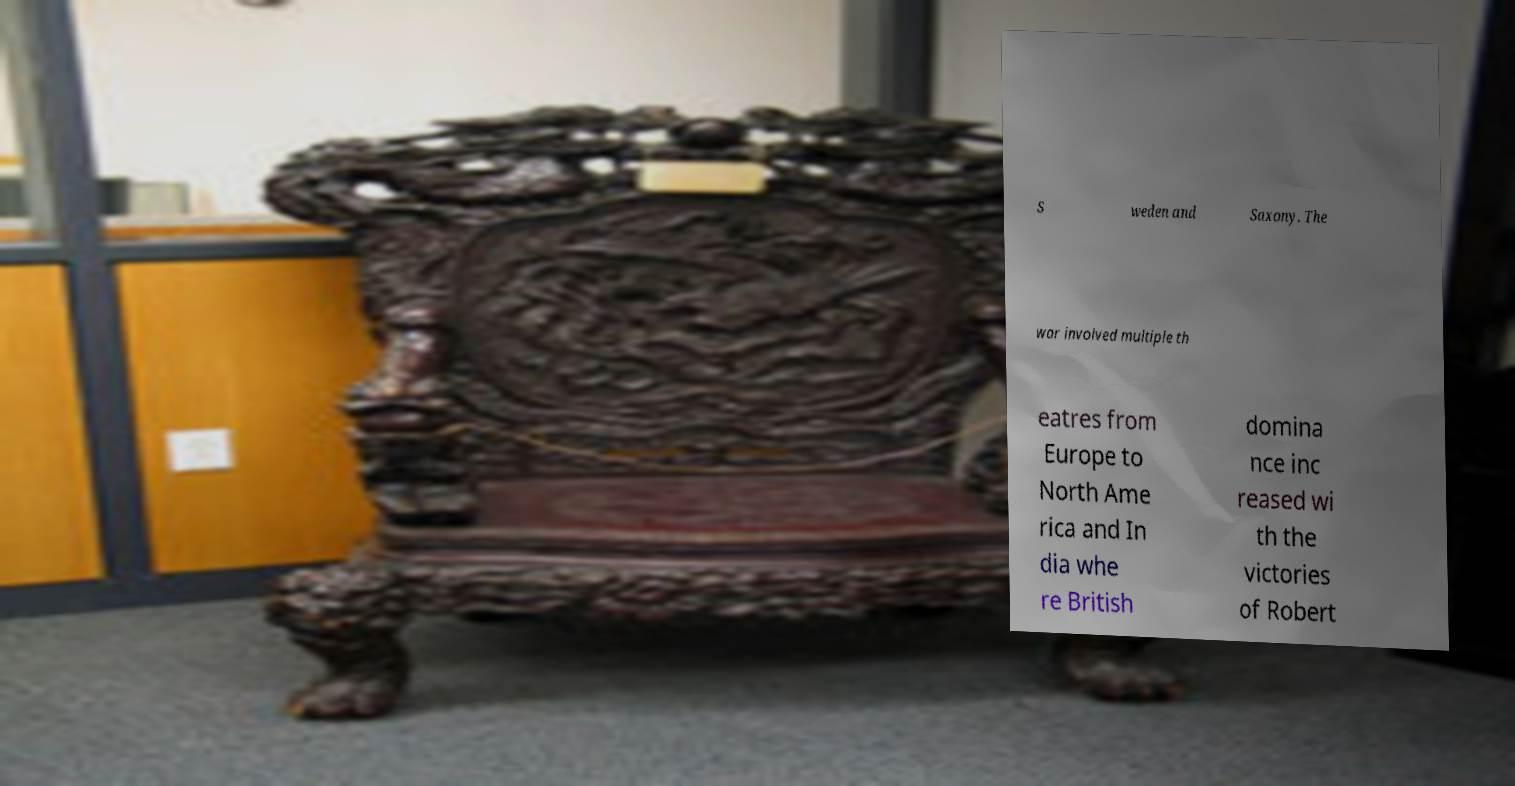Please identify and transcribe the text found in this image. S weden and Saxony. The war involved multiple th eatres from Europe to North Ame rica and In dia whe re British domina nce inc reased wi th the victories of Robert 